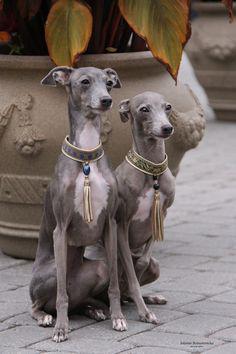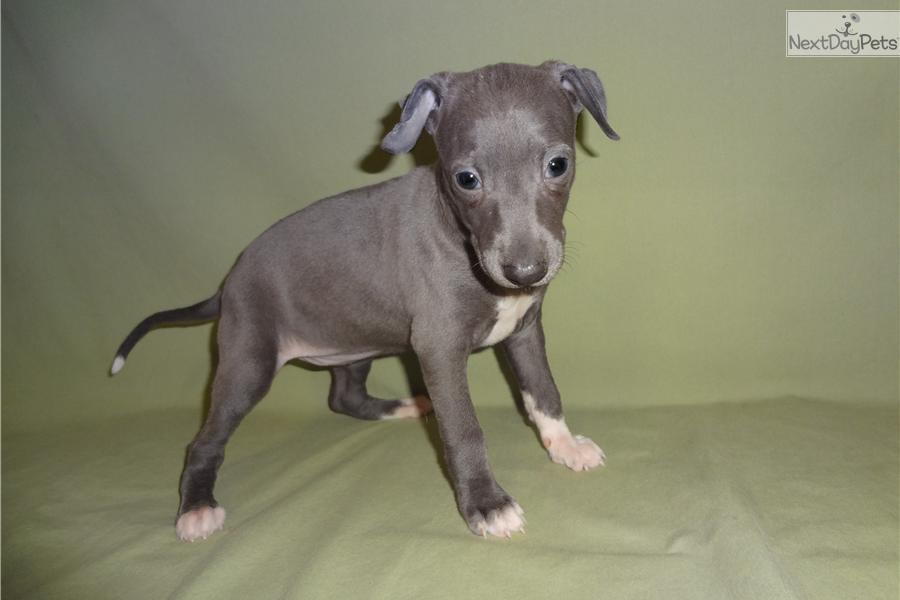The first image is the image on the left, the second image is the image on the right. Assess this claim about the two images: "None of the dogs are wearing collars.". Correct or not? Answer yes or no. No. The first image is the image on the left, the second image is the image on the right. Examine the images to the left and right. Is the description "There are at least four gray and white puppies." accurate? Answer yes or no. No. 